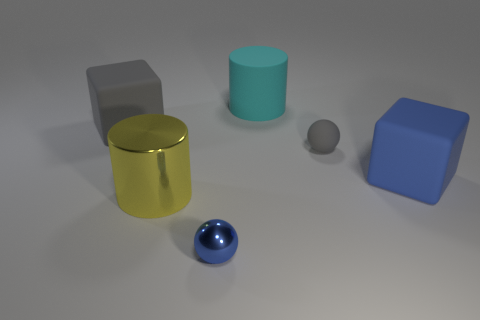Are the large cylinder in front of the cyan matte cylinder and the blue object in front of the big blue matte thing made of the same material?
Provide a succinct answer. Yes. What is the shape of the large thing to the left of the yellow metallic cylinder?
Give a very brief answer. Cube. Are there fewer tiny yellow shiny blocks than tiny blue metallic spheres?
Ensure brevity in your answer.  Yes. There is a big matte block behind the sphere behind the large yellow shiny object; are there any large gray rubber blocks on the right side of it?
Ensure brevity in your answer.  No. What number of rubber objects are yellow balls or big cyan things?
Your response must be concise. 1. Is the color of the matte ball the same as the big rubber cylinder?
Provide a short and direct response. No. How many gray cubes are to the right of the large gray cube?
Your answer should be compact. 0. What number of large rubber things are in front of the small gray object and on the left side of the blue cube?
Provide a succinct answer. 0. What shape is the cyan thing that is the same material as the gray block?
Keep it short and to the point. Cylinder. Do the gray object that is right of the cyan thing and the matte cube to the left of the big cyan cylinder have the same size?
Make the answer very short. No. 